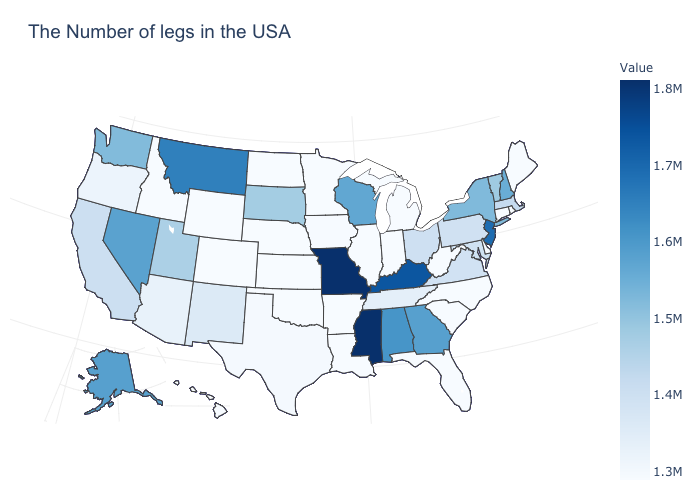Which states have the highest value in the USA?
Concise answer only. Mississippi. Does Idaho have the highest value in the USA?
Be succinct. No. Does Oklahoma have the lowest value in the South?
Keep it brief. Yes. Among the states that border New Jersey , which have the lowest value?
Write a very short answer. Delaware. Does Washington have the highest value in the West?
Write a very short answer. No. Does the map have missing data?
Answer briefly. No. 